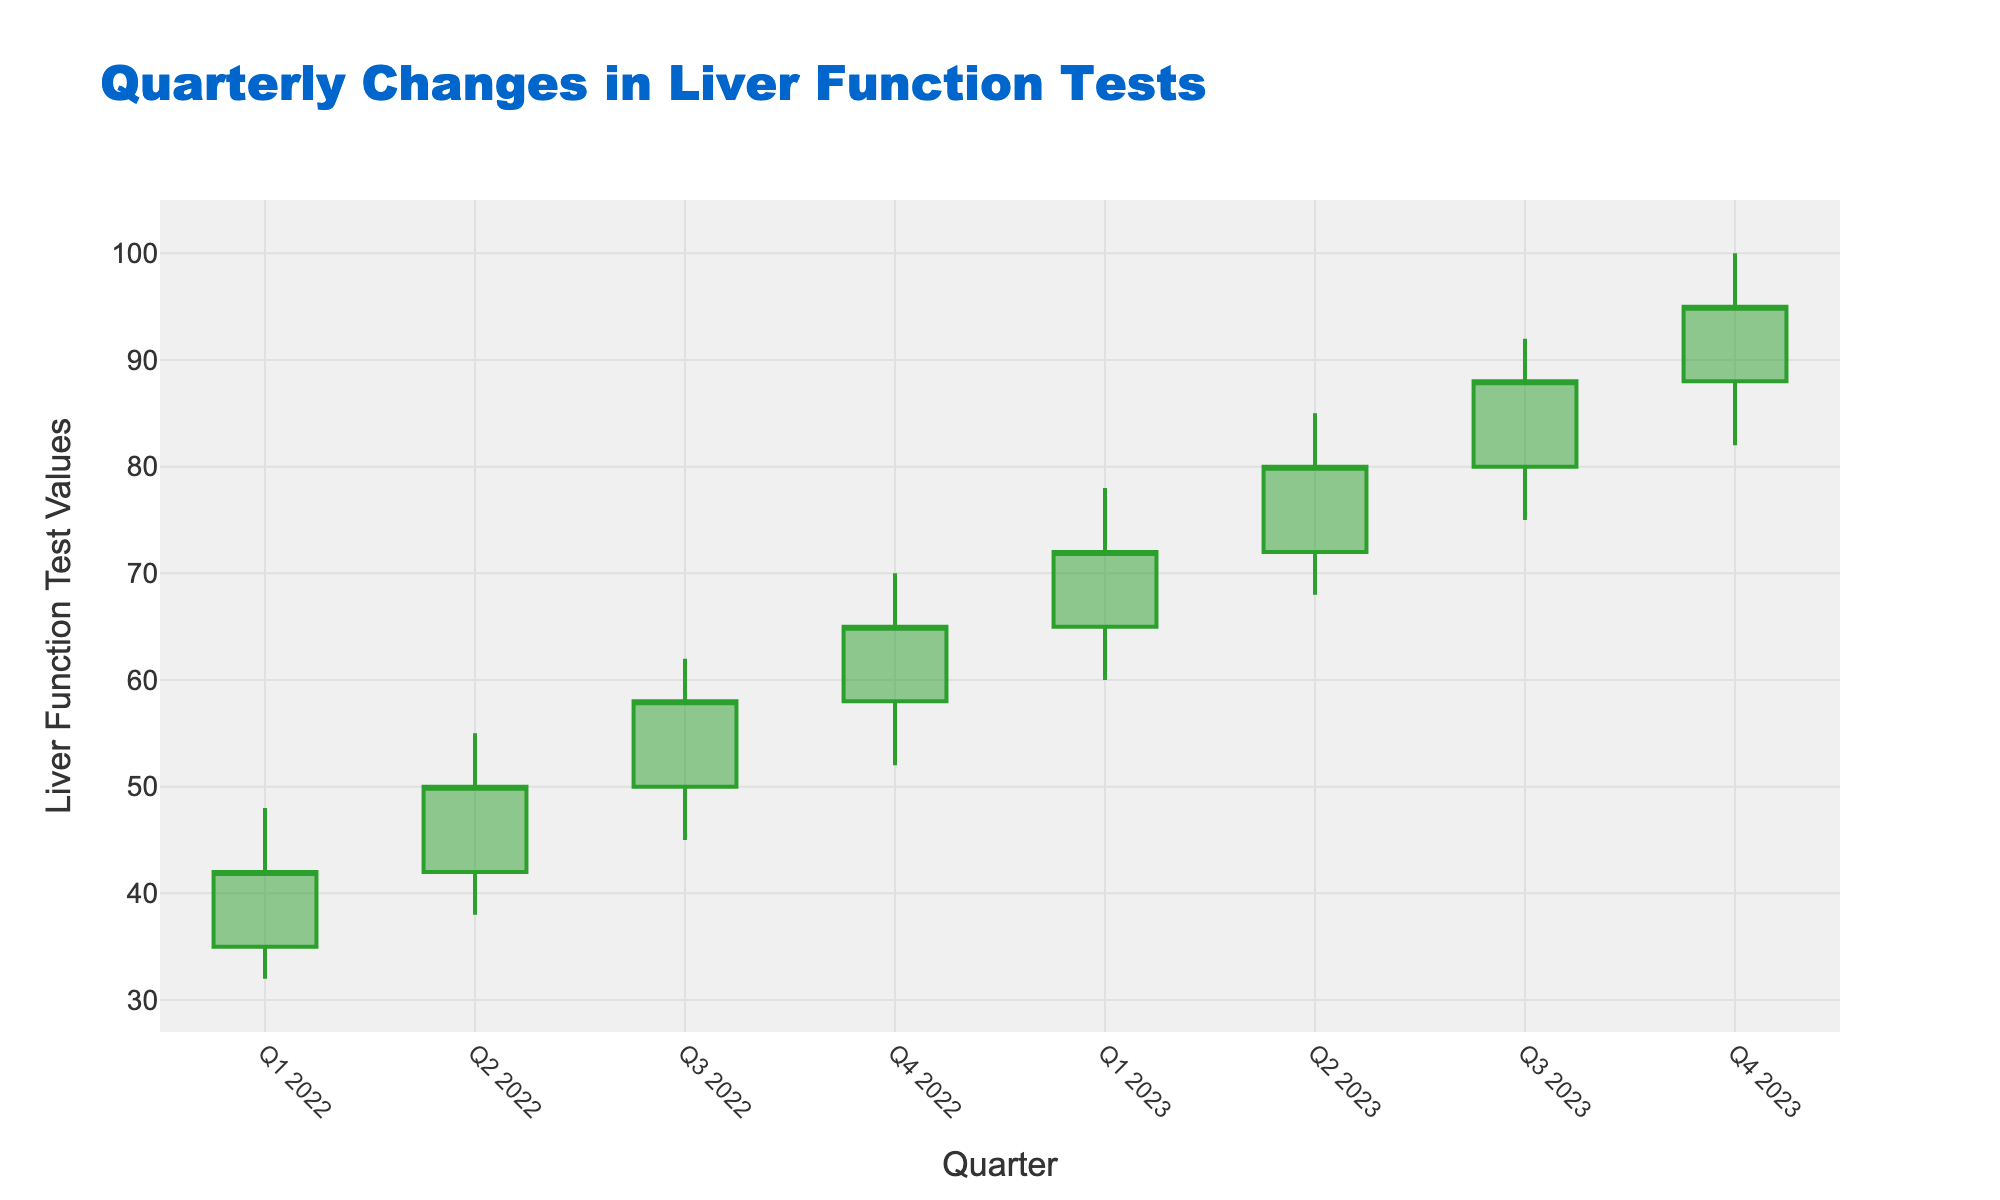What is the title of the chart? The title of the chart is usually displayed at the top of the figure. For this chart, the title is specified as 'Quarterly Changes in Liver Function Tests'.
Answer: Quarterly Changes in Liver Function Tests What is the highest value recorded in the chart, and in which quarter did it occur? The highest value is shown in the 'High' column and the respective quarter is in the 'Quarter' column. The highest value is 100, recorded in Q4 2023.
Answer: 100, Q4 2023 Which quarter has the lowest 'Low' value, and what is that value? The lowest value can be identified from the 'Low' column, and the respective quarter can be determined. The lowest value is 32, recorded in Q1 2022.
Answer: 32, Q1 2022 What’s the difference between the 'Open' value of Q1 2022 and the 'Close' value of Q4 2023? The difference is found by subtracting the 'Open' value of Q1 2022 from the 'Close' value of Q4 2023. The values are 35 and 95 respectively, so the difference is 95 - 35 = 60.
Answer: 60 How did the 'Close' value change from Q1 2022 to Q2 2022? To determine the change, subtract the 'Close' value of Q1 2022 from the 'Close' value of Q2 2022. The values are 42 and 50, so the change is 50 - 42 = 8.
Answer: Increased by 8 In which quarter did the largest increase in 'Close' value occur, and what was the increase? To find this, calculate the difference in 'Close' values between consecutive quarters and identify the largest increase. Q2 2022 to Q3 2022 shows an increase from 50 to 58, so the increase is 8.
Answer: Q2 2022 to Q3 2022, Increase of 8 What color represents an increasing trend, and what color represents a decreasing trend in the chart? The color for increasing trends is specified as '#2ca02c' (typically a shade of green), and for decreasing trends, it is '#d62728' (typically a shade of red).
Answer: Green for increasing, Red for decreasing How many quarters are displayed in the chart? Count the number of unique entries in the 'Quarter' column. There are 8 quarters displayed from Q1 2022 to Q4 2023.
Answer: 8 What is the range of the y-axis in the chart? The y-axis range can be determined by examining the 'Low' and 'High' values. The minimum 'Low' is 32, and the maximum 'High' is 100. Therefore, the y-axis range has been set to 27 to 105.
Answer: 27 to 105 